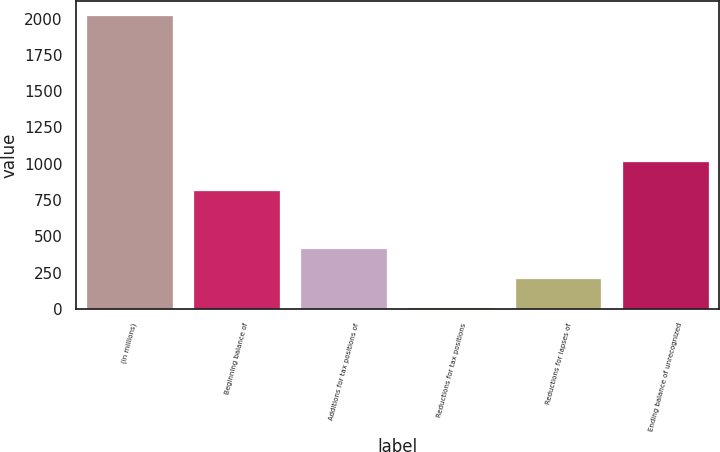<chart> <loc_0><loc_0><loc_500><loc_500><bar_chart><fcel>(in millions)<fcel>Beginning balance of<fcel>Additions for tax positions of<fcel>Reductions for tax positions<fcel>Reductions for lapses of<fcel>Ending balance of unrecognized<nl><fcel>2018<fcel>811.4<fcel>409.2<fcel>7<fcel>208.1<fcel>1012.5<nl></chart> 